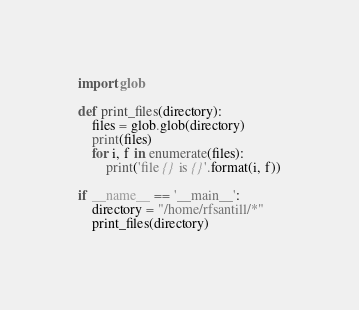Convert code to text. <code><loc_0><loc_0><loc_500><loc_500><_Python_>
import glob

def print_files(directory):
    files = glob.glob(directory) 
    print(files)
    for i, f in enumerate(files):
        print('file {} is {}'.format(i, f))

if __name__ == '__main__':
    directory = "/home/rfsantill/*"
    print_files(directory)
</code> 